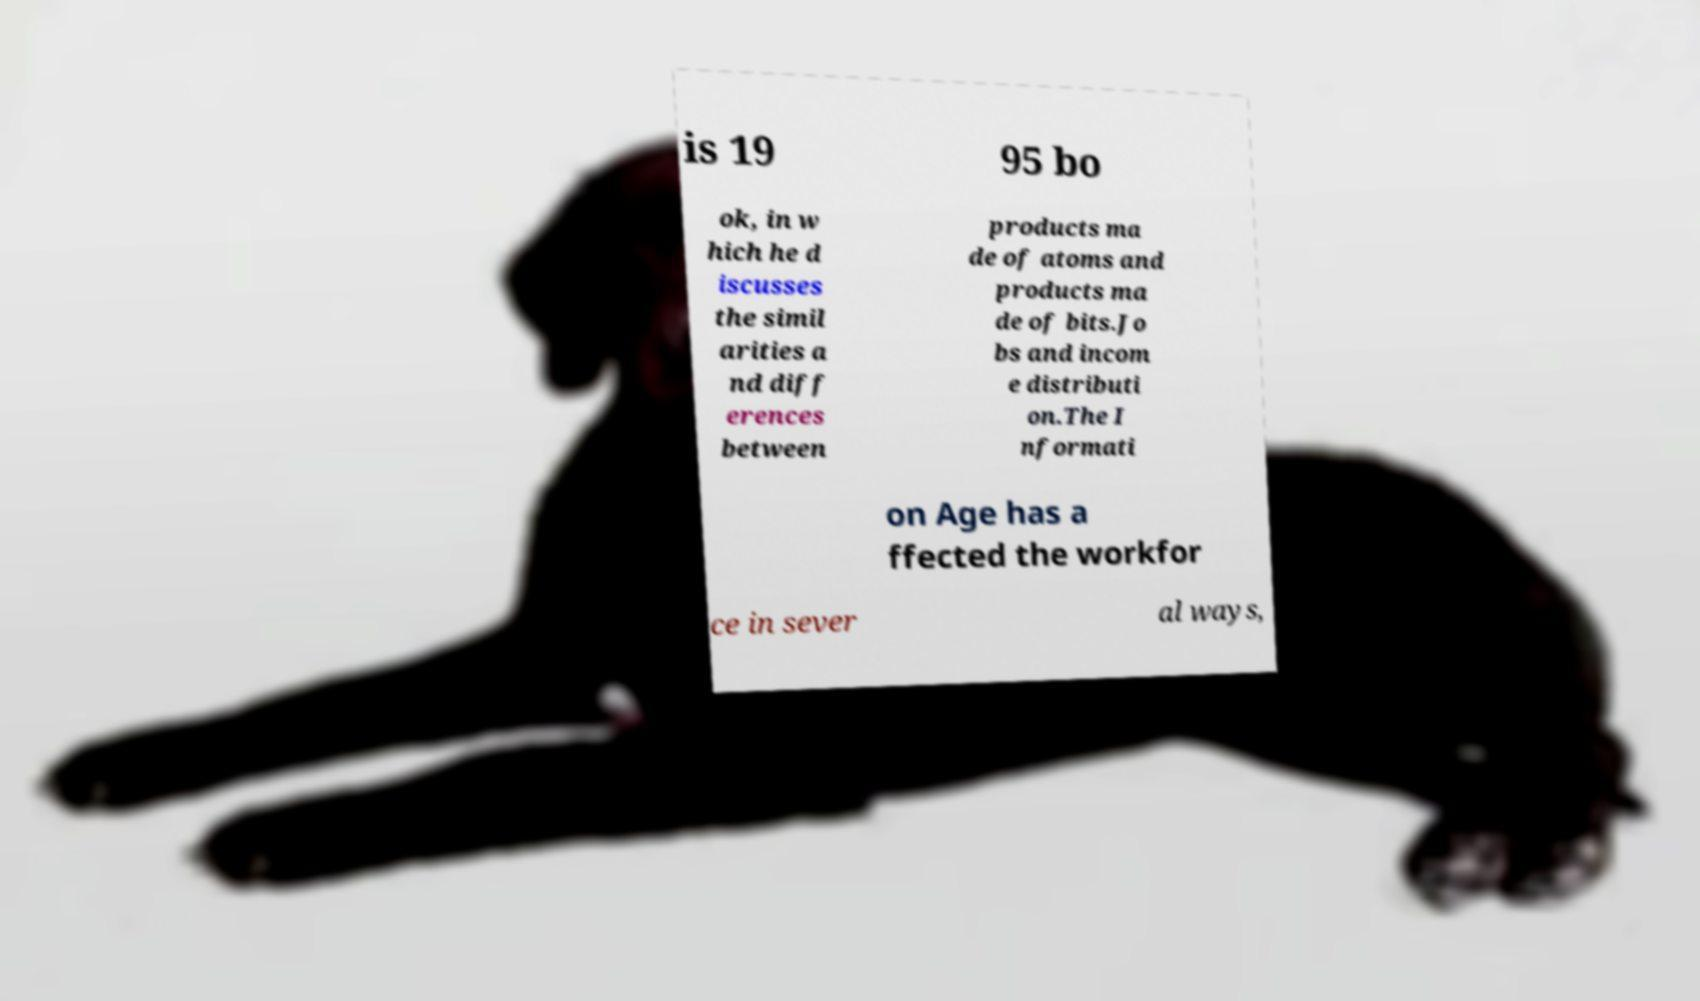Could you extract and type out the text from this image? is 19 95 bo ok, in w hich he d iscusses the simil arities a nd diff erences between products ma de of atoms and products ma de of bits.Jo bs and incom e distributi on.The I nformati on Age has a ffected the workfor ce in sever al ways, 